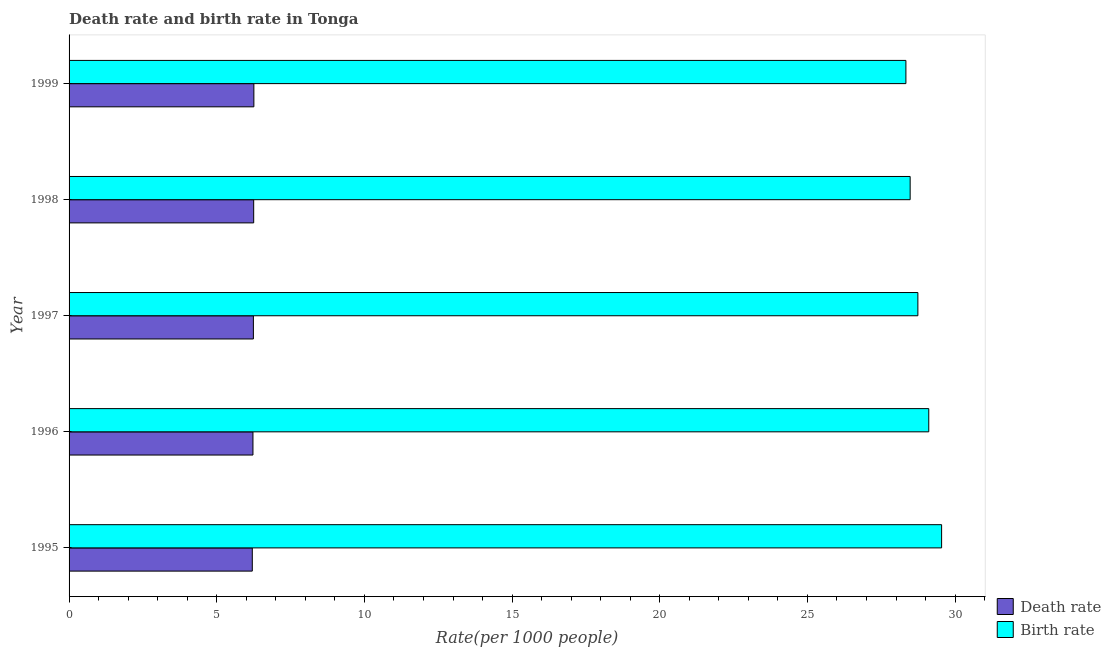How many different coloured bars are there?
Your answer should be very brief. 2. Are the number of bars on each tick of the Y-axis equal?
Provide a short and direct response. Yes. How many bars are there on the 1st tick from the bottom?
Your response must be concise. 2. What is the label of the 4th group of bars from the top?
Keep it short and to the point. 1996. In how many cases, is the number of bars for a given year not equal to the number of legend labels?
Your response must be concise. 0. What is the death rate in 1998?
Your response must be concise. 6.25. Across all years, what is the maximum birth rate?
Provide a short and direct response. 29.54. Across all years, what is the minimum birth rate?
Make the answer very short. 28.33. What is the total death rate in the graph?
Ensure brevity in your answer.  31.18. What is the difference between the death rate in 1997 and that in 1999?
Make the answer very short. -0.02. What is the difference between the death rate in 1999 and the birth rate in 1998?
Give a very brief answer. -22.22. What is the average birth rate per year?
Your answer should be compact. 28.84. In the year 1997, what is the difference between the death rate and birth rate?
Your answer should be compact. -22.5. Is the birth rate in 1995 less than that in 1998?
Ensure brevity in your answer.  No. What is the difference between the highest and the second highest birth rate?
Your answer should be very brief. 0.43. Is the sum of the birth rate in 1998 and 1999 greater than the maximum death rate across all years?
Offer a terse response. Yes. What does the 2nd bar from the top in 1999 represents?
Offer a very short reply. Death rate. What does the 2nd bar from the bottom in 1997 represents?
Keep it short and to the point. Birth rate. How many bars are there?
Ensure brevity in your answer.  10. Are all the bars in the graph horizontal?
Provide a succinct answer. Yes. Are the values on the major ticks of X-axis written in scientific E-notation?
Keep it short and to the point. No. Does the graph contain any zero values?
Your answer should be very brief. No. Does the graph contain grids?
Give a very brief answer. No. How many legend labels are there?
Keep it short and to the point. 2. What is the title of the graph?
Provide a succinct answer. Death rate and birth rate in Tonga. What is the label or title of the X-axis?
Your response must be concise. Rate(per 1000 people). What is the Rate(per 1000 people) in Death rate in 1995?
Provide a succinct answer. 6.2. What is the Rate(per 1000 people) in Birth rate in 1995?
Your answer should be very brief. 29.54. What is the Rate(per 1000 people) in Death rate in 1996?
Offer a terse response. 6.23. What is the Rate(per 1000 people) in Birth rate in 1996?
Your answer should be very brief. 29.11. What is the Rate(per 1000 people) of Death rate in 1997?
Your response must be concise. 6.24. What is the Rate(per 1000 people) of Birth rate in 1997?
Ensure brevity in your answer.  28.74. What is the Rate(per 1000 people) in Death rate in 1998?
Make the answer very short. 6.25. What is the Rate(per 1000 people) in Birth rate in 1998?
Provide a short and direct response. 28.48. What is the Rate(per 1000 people) of Death rate in 1999?
Provide a succinct answer. 6.26. What is the Rate(per 1000 people) of Birth rate in 1999?
Provide a succinct answer. 28.33. Across all years, what is the maximum Rate(per 1000 people) of Death rate?
Your response must be concise. 6.26. Across all years, what is the maximum Rate(per 1000 people) in Birth rate?
Your answer should be very brief. 29.54. Across all years, what is the minimum Rate(per 1000 people) of Death rate?
Your response must be concise. 6.2. Across all years, what is the minimum Rate(per 1000 people) in Birth rate?
Give a very brief answer. 28.33. What is the total Rate(per 1000 people) of Death rate in the graph?
Offer a terse response. 31.18. What is the total Rate(per 1000 people) of Birth rate in the graph?
Ensure brevity in your answer.  144.2. What is the difference between the Rate(per 1000 people) in Death rate in 1995 and that in 1996?
Your answer should be compact. -0.02. What is the difference between the Rate(per 1000 people) in Birth rate in 1995 and that in 1996?
Offer a very short reply. 0.43. What is the difference between the Rate(per 1000 people) of Death rate in 1995 and that in 1997?
Your answer should be compact. -0.04. What is the difference between the Rate(per 1000 people) of Birth rate in 1995 and that in 1997?
Keep it short and to the point. 0.8. What is the difference between the Rate(per 1000 people) of Death rate in 1995 and that in 1998?
Ensure brevity in your answer.  -0.05. What is the difference between the Rate(per 1000 people) of Birth rate in 1995 and that in 1998?
Keep it short and to the point. 1.06. What is the difference between the Rate(per 1000 people) in Death rate in 1995 and that in 1999?
Offer a terse response. -0.05. What is the difference between the Rate(per 1000 people) in Birth rate in 1995 and that in 1999?
Provide a succinct answer. 1.21. What is the difference between the Rate(per 1000 people) in Death rate in 1996 and that in 1997?
Offer a terse response. -0.01. What is the difference between the Rate(per 1000 people) in Birth rate in 1996 and that in 1997?
Your answer should be very brief. 0.37. What is the difference between the Rate(per 1000 people) of Death rate in 1996 and that in 1998?
Your answer should be very brief. -0.03. What is the difference between the Rate(per 1000 people) in Birth rate in 1996 and that in 1998?
Give a very brief answer. 0.63. What is the difference between the Rate(per 1000 people) in Death rate in 1996 and that in 1999?
Give a very brief answer. -0.03. What is the difference between the Rate(per 1000 people) of Birth rate in 1996 and that in 1999?
Your response must be concise. 0.77. What is the difference between the Rate(per 1000 people) of Death rate in 1997 and that in 1998?
Offer a terse response. -0.01. What is the difference between the Rate(per 1000 people) of Birth rate in 1997 and that in 1998?
Your answer should be compact. 0.26. What is the difference between the Rate(per 1000 people) in Death rate in 1997 and that in 1999?
Make the answer very short. -0.02. What is the difference between the Rate(per 1000 people) of Birth rate in 1997 and that in 1999?
Provide a succinct answer. 0.41. What is the difference between the Rate(per 1000 people) in Death rate in 1998 and that in 1999?
Offer a terse response. -0.01. What is the difference between the Rate(per 1000 people) of Birth rate in 1998 and that in 1999?
Your response must be concise. 0.14. What is the difference between the Rate(per 1000 people) in Death rate in 1995 and the Rate(per 1000 people) in Birth rate in 1996?
Keep it short and to the point. -22.9. What is the difference between the Rate(per 1000 people) of Death rate in 1995 and the Rate(per 1000 people) of Birth rate in 1997?
Your answer should be very brief. -22.54. What is the difference between the Rate(per 1000 people) of Death rate in 1995 and the Rate(per 1000 people) of Birth rate in 1998?
Give a very brief answer. -22.27. What is the difference between the Rate(per 1000 people) of Death rate in 1995 and the Rate(per 1000 people) of Birth rate in 1999?
Make the answer very short. -22.13. What is the difference between the Rate(per 1000 people) in Death rate in 1996 and the Rate(per 1000 people) in Birth rate in 1997?
Make the answer very short. -22.51. What is the difference between the Rate(per 1000 people) of Death rate in 1996 and the Rate(per 1000 people) of Birth rate in 1998?
Your answer should be very brief. -22.25. What is the difference between the Rate(per 1000 people) of Death rate in 1996 and the Rate(per 1000 people) of Birth rate in 1999?
Make the answer very short. -22.11. What is the difference between the Rate(per 1000 people) in Death rate in 1997 and the Rate(per 1000 people) in Birth rate in 1998?
Provide a succinct answer. -22.24. What is the difference between the Rate(per 1000 people) of Death rate in 1997 and the Rate(per 1000 people) of Birth rate in 1999?
Your answer should be compact. -22.09. What is the difference between the Rate(per 1000 people) in Death rate in 1998 and the Rate(per 1000 people) in Birth rate in 1999?
Offer a terse response. -22.08. What is the average Rate(per 1000 people) of Death rate per year?
Provide a succinct answer. 6.24. What is the average Rate(per 1000 people) of Birth rate per year?
Keep it short and to the point. 28.84. In the year 1995, what is the difference between the Rate(per 1000 people) in Death rate and Rate(per 1000 people) in Birth rate?
Offer a very short reply. -23.34. In the year 1996, what is the difference between the Rate(per 1000 people) of Death rate and Rate(per 1000 people) of Birth rate?
Your answer should be very brief. -22.88. In the year 1997, what is the difference between the Rate(per 1000 people) in Death rate and Rate(per 1000 people) in Birth rate?
Provide a succinct answer. -22.5. In the year 1998, what is the difference between the Rate(per 1000 people) in Death rate and Rate(per 1000 people) in Birth rate?
Provide a succinct answer. -22.23. In the year 1999, what is the difference between the Rate(per 1000 people) in Death rate and Rate(per 1000 people) in Birth rate?
Give a very brief answer. -22.08. What is the ratio of the Rate(per 1000 people) of Death rate in 1995 to that in 1996?
Give a very brief answer. 1. What is the ratio of the Rate(per 1000 people) of Birth rate in 1995 to that in 1996?
Provide a succinct answer. 1.01. What is the ratio of the Rate(per 1000 people) in Birth rate in 1995 to that in 1997?
Offer a very short reply. 1.03. What is the ratio of the Rate(per 1000 people) in Death rate in 1995 to that in 1998?
Give a very brief answer. 0.99. What is the ratio of the Rate(per 1000 people) in Birth rate in 1995 to that in 1998?
Provide a short and direct response. 1.04. What is the ratio of the Rate(per 1000 people) of Death rate in 1995 to that in 1999?
Your answer should be very brief. 0.99. What is the ratio of the Rate(per 1000 people) of Birth rate in 1995 to that in 1999?
Offer a terse response. 1.04. What is the ratio of the Rate(per 1000 people) of Death rate in 1996 to that in 1997?
Ensure brevity in your answer.  1. What is the ratio of the Rate(per 1000 people) of Birth rate in 1996 to that in 1997?
Provide a short and direct response. 1.01. What is the ratio of the Rate(per 1000 people) in Birth rate in 1996 to that in 1998?
Offer a terse response. 1.02. What is the ratio of the Rate(per 1000 people) of Birth rate in 1996 to that in 1999?
Ensure brevity in your answer.  1.03. What is the ratio of the Rate(per 1000 people) of Death rate in 1997 to that in 1998?
Provide a succinct answer. 1. What is the ratio of the Rate(per 1000 people) of Birth rate in 1997 to that in 1998?
Your answer should be very brief. 1.01. What is the ratio of the Rate(per 1000 people) in Death rate in 1997 to that in 1999?
Give a very brief answer. 1. What is the ratio of the Rate(per 1000 people) in Birth rate in 1997 to that in 1999?
Give a very brief answer. 1.01. What is the ratio of the Rate(per 1000 people) in Death rate in 1998 to that in 1999?
Your response must be concise. 1. What is the difference between the highest and the second highest Rate(per 1000 people) in Death rate?
Your response must be concise. 0.01. What is the difference between the highest and the second highest Rate(per 1000 people) in Birth rate?
Ensure brevity in your answer.  0.43. What is the difference between the highest and the lowest Rate(per 1000 people) in Death rate?
Provide a succinct answer. 0.05. What is the difference between the highest and the lowest Rate(per 1000 people) in Birth rate?
Provide a short and direct response. 1.21. 